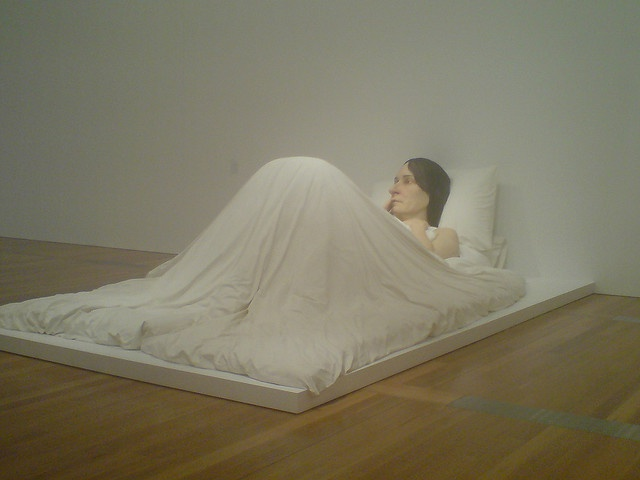Describe the objects in this image and their specific colors. I can see bed in gray and darkgray tones and people in gray, tan, and darkgreen tones in this image. 